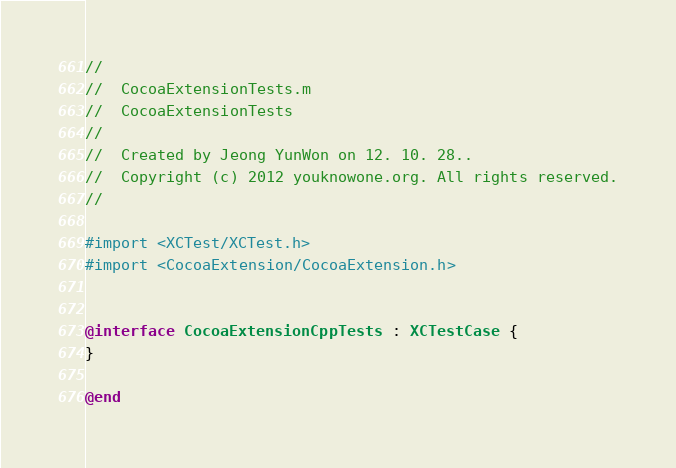Convert code to text. <code><loc_0><loc_0><loc_500><loc_500><_ObjectiveC_>//
//  CocoaExtensionTests.m
//  CocoaExtensionTests
//
//  Created by Jeong YunWon on 12. 10. 28..
//  Copyright (c) 2012 youknowone.org. All rights reserved.
//

#import <XCTest/XCTest.h>
#import <CocoaExtension/CocoaExtension.h>


@interface CocoaExtensionCppTests : XCTestCase {
}

@end

</code> 